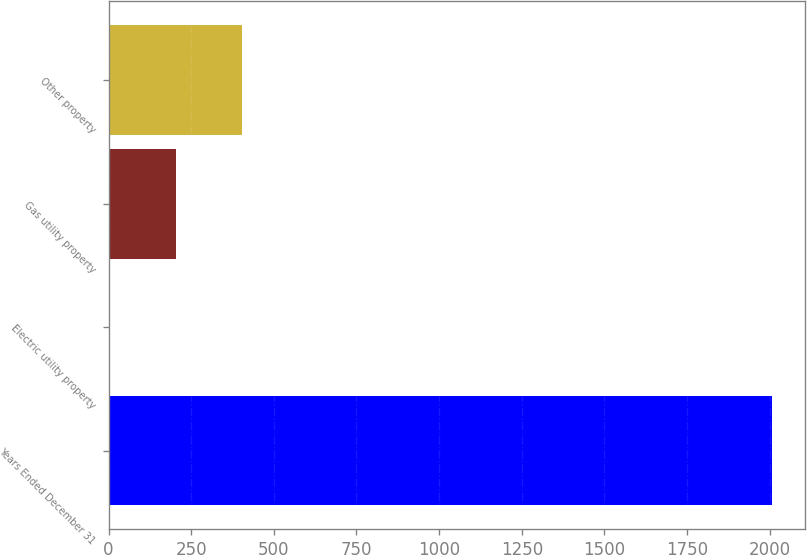<chart> <loc_0><loc_0><loc_500><loc_500><bar_chart><fcel>Years Ended December 31<fcel>Electric utility property<fcel>Gas utility property<fcel>Other property<nl><fcel>2007<fcel>3<fcel>203.4<fcel>403.8<nl></chart> 